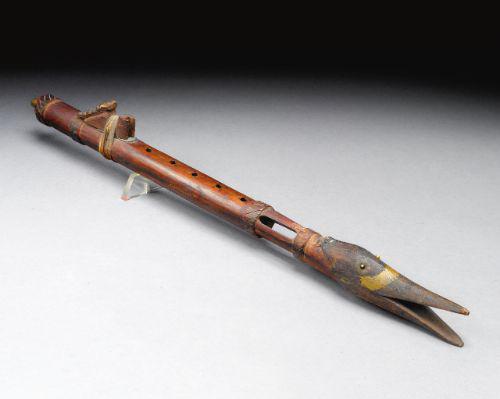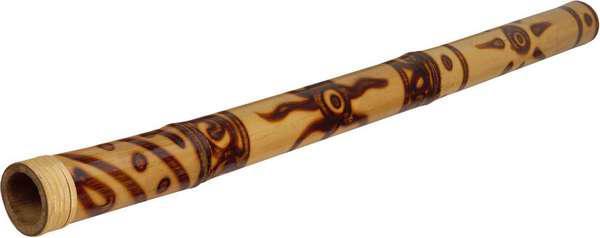The first image is the image on the left, the second image is the image on the right. Considering the images on both sides, is "Both flutes are angled from bottom left to top right." valid? Answer yes or no. No. The first image is the image on the left, the second image is the image on the right. For the images displayed, is the sentence "The flutes displayed on the left and right angle toward each other, and the flute on the right is decorated with tribal motifs." factually correct? Answer yes or no. Yes. 